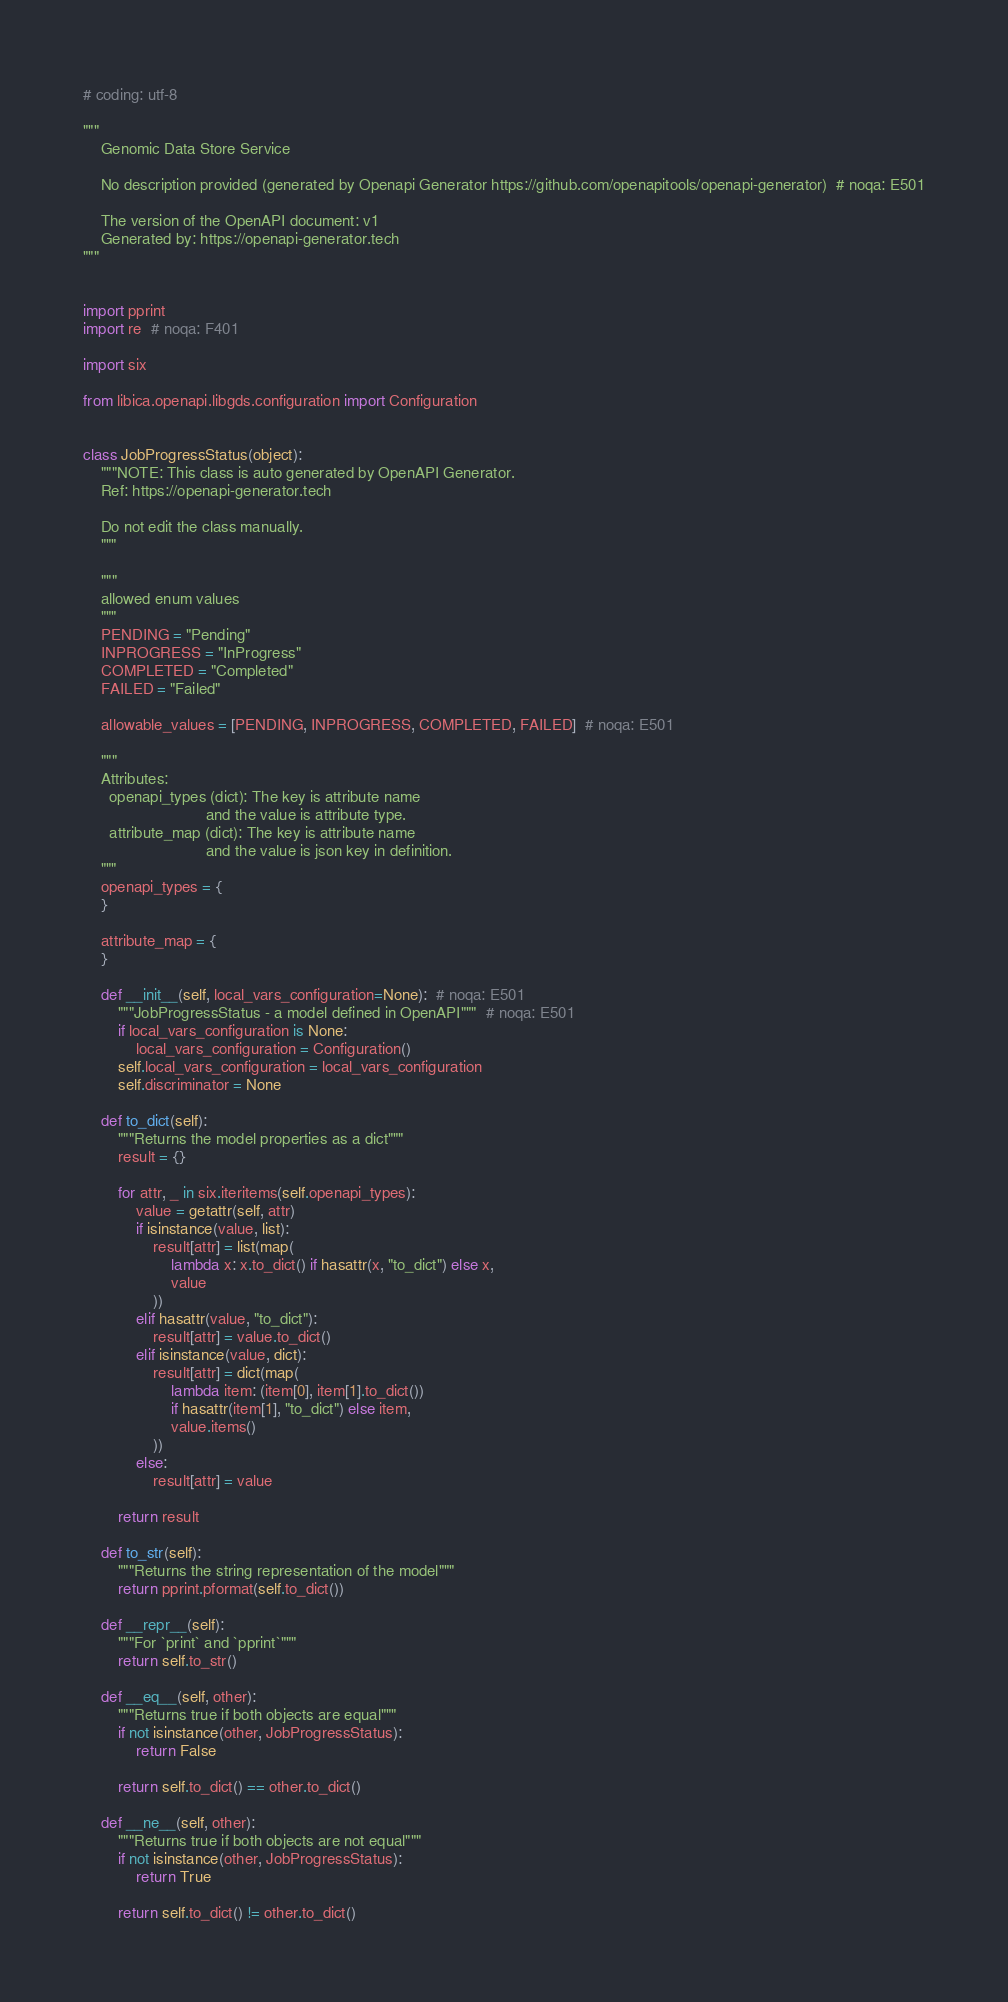Convert code to text. <code><loc_0><loc_0><loc_500><loc_500><_Python_># coding: utf-8

"""
    Genomic Data Store Service

    No description provided (generated by Openapi Generator https://github.com/openapitools/openapi-generator)  # noqa: E501

    The version of the OpenAPI document: v1
    Generated by: https://openapi-generator.tech
"""


import pprint
import re  # noqa: F401

import six

from libica.openapi.libgds.configuration import Configuration


class JobProgressStatus(object):
    """NOTE: This class is auto generated by OpenAPI Generator.
    Ref: https://openapi-generator.tech

    Do not edit the class manually.
    """

    """
    allowed enum values
    """
    PENDING = "Pending"
    INPROGRESS = "InProgress"
    COMPLETED = "Completed"
    FAILED = "Failed"

    allowable_values = [PENDING, INPROGRESS, COMPLETED, FAILED]  # noqa: E501

    """
    Attributes:
      openapi_types (dict): The key is attribute name
                            and the value is attribute type.
      attribute_map (dict): The key is attribute name
                            and the value is json key in definition.
    """
    openapi_types = {
    }

    attribute_map = {
    }

    def __init__(self, local_vars_configuration=None):  # noqa: E501
        """JobProgressStatus - a model defined in OpenAPI"""  # noqa: E501
        if local_vars_configuration is None:
            local_vars_configuration = Configuration()
        self.local_vars_configuration = local_vars_configuration
        self.discriminator = None

    def to_dict(self):
        """Returns the model properties as a dict"""
        result = {}

        for attr, _ in six.iteritems(self.openapi_types):
            value = getattr(self, attr)
            if isinstance(value, list):
                result[attr] = list(map(
                    lambda x: x.to_dict() if hasattr(x, "to_dict") else x,
                    value
                ))
            elif hasattr(value, "to_dict"):
                result[attr] = value.to_dict()
            elif isinstance(value, dict):
                result[attr] = dict(map(
                    lambda item: (item[0], item[1].to_dict())
                    if hasattr(item[1], "to_dict") else item,
                    value.items()
                ))
            else:
                result[attr] = value

        return result

    def to_str(self):
        """Returns the string representation of the model"""
        return pprint.pformat(self.to_dict())

    def __repr__(self):
        """For `print` and `pprint`"""
        return self.to_str()

    def __eq__(self, other):
        """Returns true if both objects are equal"""
        if not isinstance(other, JobProgressStatus):
            return False

        return self.to_dict() == other.to_dict()

    def __ne__(self, other):
        """Returns true if both objects are not equal"""
        if not isinstance(other, JobProgressStatus):
            return True

        return self.to_dict() != other.to_dict()
</code> 